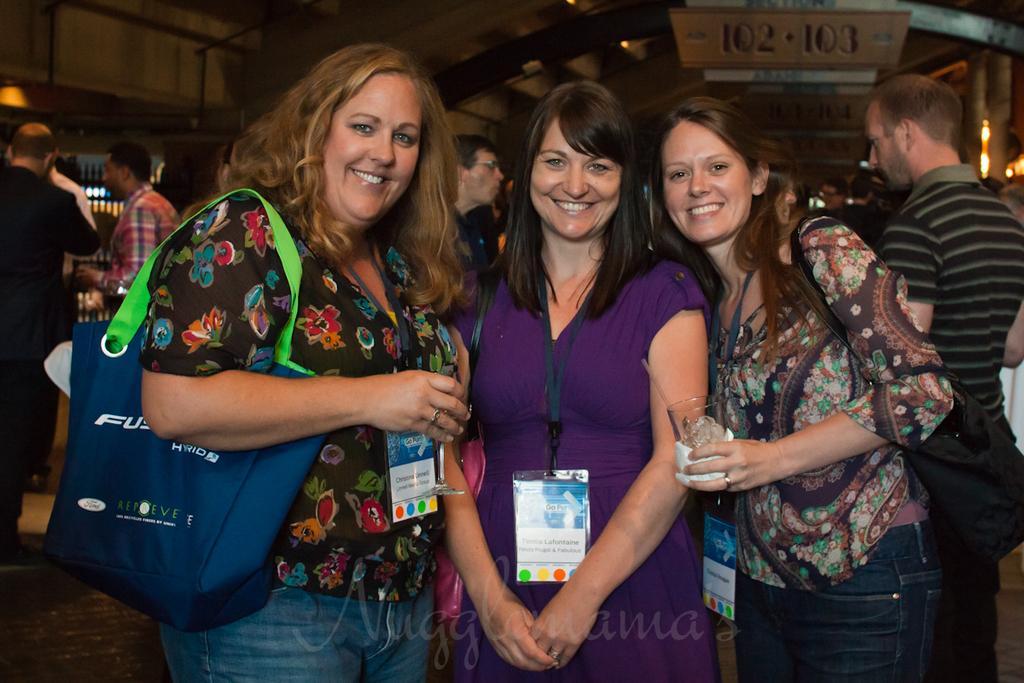In one or two sentences, can you explain what this image depicts? In this picture we can see some people standing here, a woman on the left side is carrying a bag, in the background we can see boards, there is a light here. 